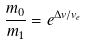<formula> <loc_0><loc_0><loc_500><loc_500>\frac { m _ { 0 } } { m _ { 1 } } = e ^ { \Delta v / v _ { e } }</formula> 